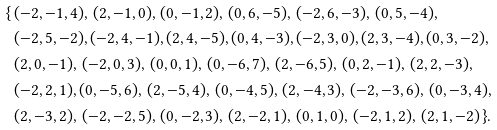Convert formula to latex. <formula><loc_0><loc_0><loc_500><loc_500>\{ \, & ( - 2 , - 1 , 4 ) , \, ( 2 , - 1 , 0 ) , \, ( 0 , - 1 , 2 ) , \, ( 0 , 6 , - 5 ) , \, ( - 2 , 6 , - 3 ) , \, ( 0 , 5 , - 4 ) , \, \\ & ( - 2 , 5 , - 2 ) , ( - 2 , 4 , - 1 ) , ( 2 , 4 , - 5 ) , ( 0 , 4 , - 3 ) , ( - 2 , 3 , 0 ) , ( 2 , 3 , - 4 ) , ( 0 , 3 , - 2 ) , \\ & ( 2 , 0 , - 1 ) , \, ( - 2 , 0 , 3 ) , \, ( 0 , 0 , 1 ) , \, ( 0 , - 6 , 7 ) , \, ( 2 , - 6 , 5 ) , \, ( 0 , 2 , - 1 ) , \, ( 2 , 2 , - 3 ) , \\ & ( - 2 , 2 , 1 ) , ( 0 , - 5 , 6 ) , \, ( 2 , - 5 , 4 ) , \, ( 0 , - 4 , 5 ) , \, ( 2 , - 4 , 3 ) , \, ( - 2 , - 3 , 6 ) , \, ( 0 , - 3 , 4 ) , \\ & ( 2 , - 3 , 2 ) , \, ( - 2 , - 2 , 5 ) , \, ( 0 , - 2 , 3 ) , \, ( 2 , - 2 , 1 ) , \, ( 0 , 1 , 0 ) , \, ( - 2 , 1 , 2 ) , \, ( 2 , 1 , - 2 ) \, \} .</formula> 